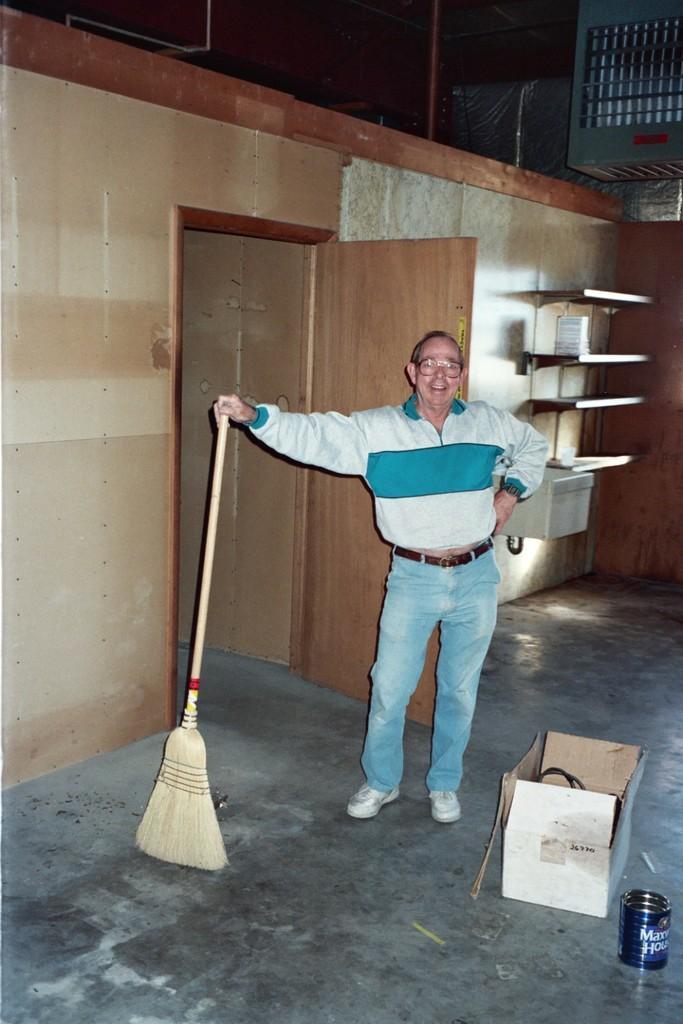In one or two sentences, can you explain what this image depicts? In this image there is a man standing. He is smiling. He is holding a broom in his hand. To the right there is a box on the floor. Beside the box there is a tin. To the left there is a door to the wall. In the background there are wooden shelves. 